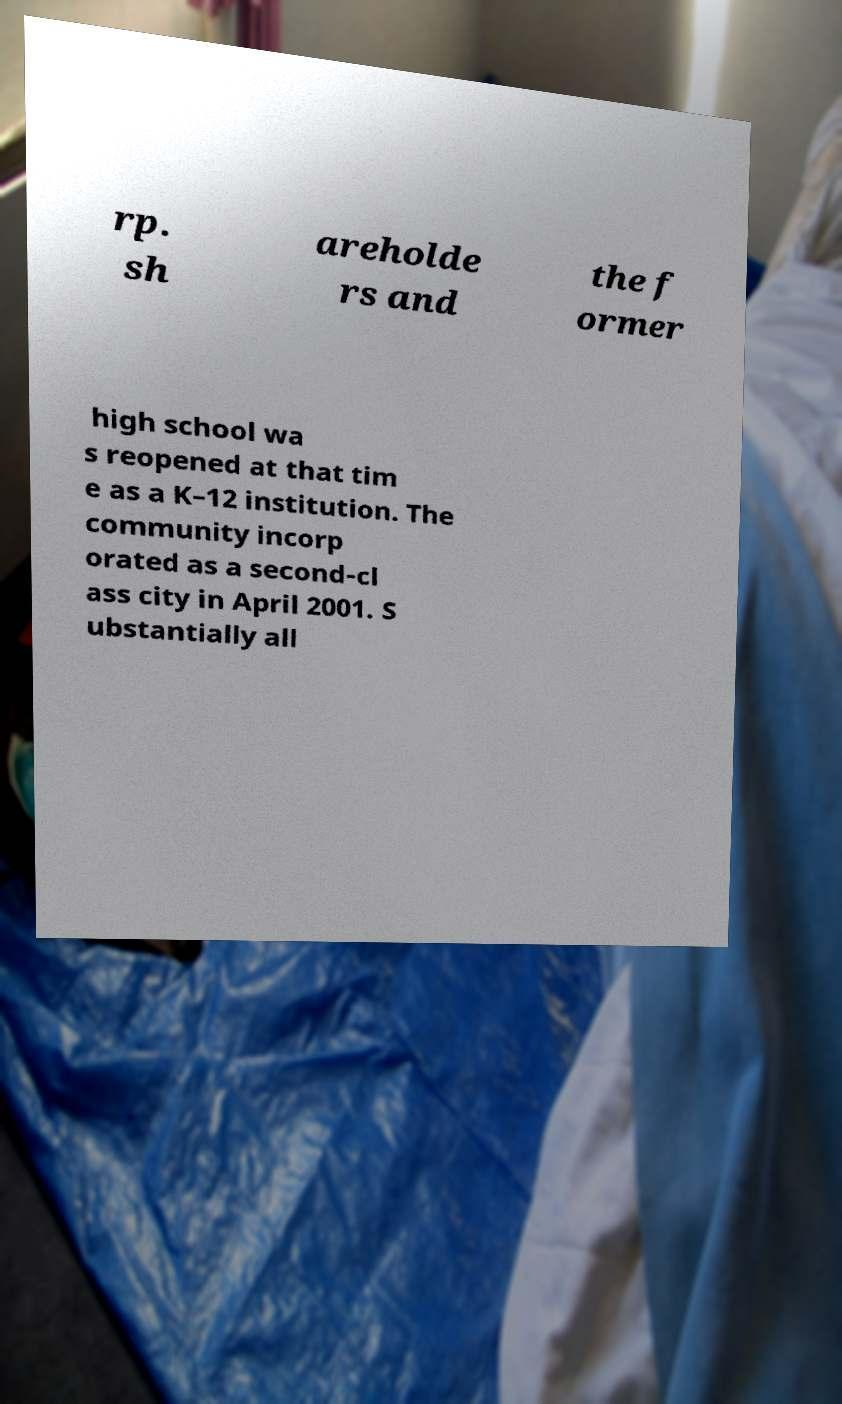What messages or text are displayed in this image? I need them in a readable, typed format. rp. sh areholde rs and the f ormer high school wa s reopened at that tim e as a K–12 institution. The community incorp orated as a second-cl ass city in April 2001. S ubstantially all 